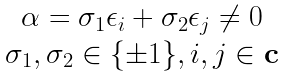Convert formula to latex. <formula><loc_0><loc_0><loc_500><loc_500>\begin{matrix} \alpha = \sigma _ { 1 } \epsilon _ { i } + \sigma _ { 2 } \epsilon _ { j } \neq 0 \\ \sigma _ { 1 } , \sigma _ { 2 } \in \{ \pm 1 \} , i , j \in \mathbf c \end{matrix}</formula> 